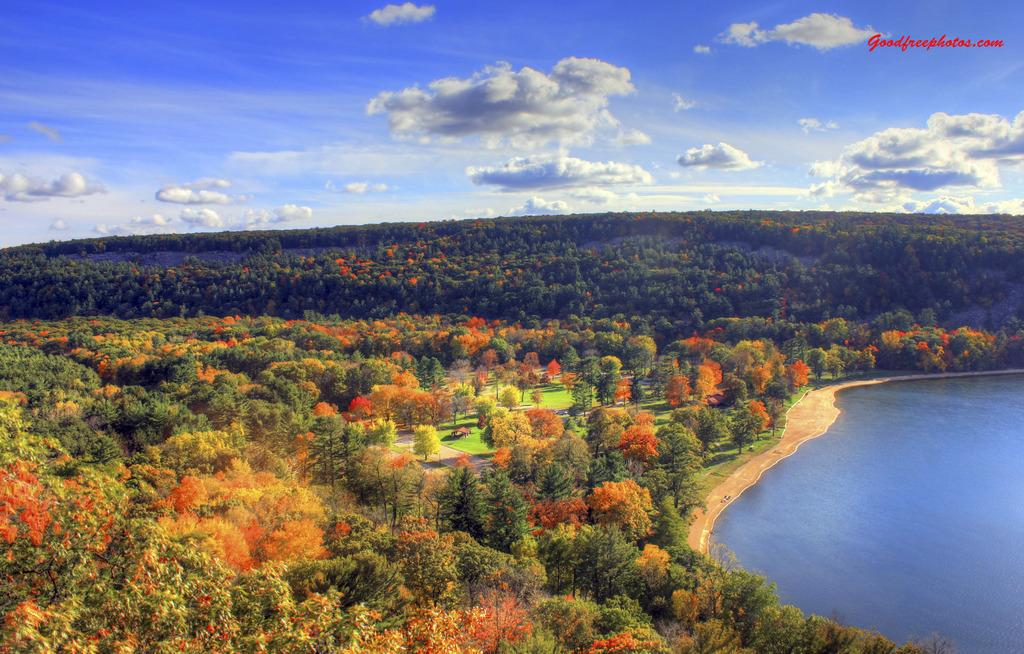What is the primary element visible in the image? There is water in the image. What type of vegetation can be seen in the image? There are trees in the image. How would you describe the sky in the image? The sky is cloudy in the image. Is there any additional marking or feature on the image? Yes, there is a watermark on the image. What type of riddle can be seen floating on the water in the image? There is no riddle present in the image; it features water, trees, and a cloudy sky. Can you tell me how many rifles are hidden among the trees in the image? There are no rifles present in the image; it only features water, trees, and a cloudy sky. 